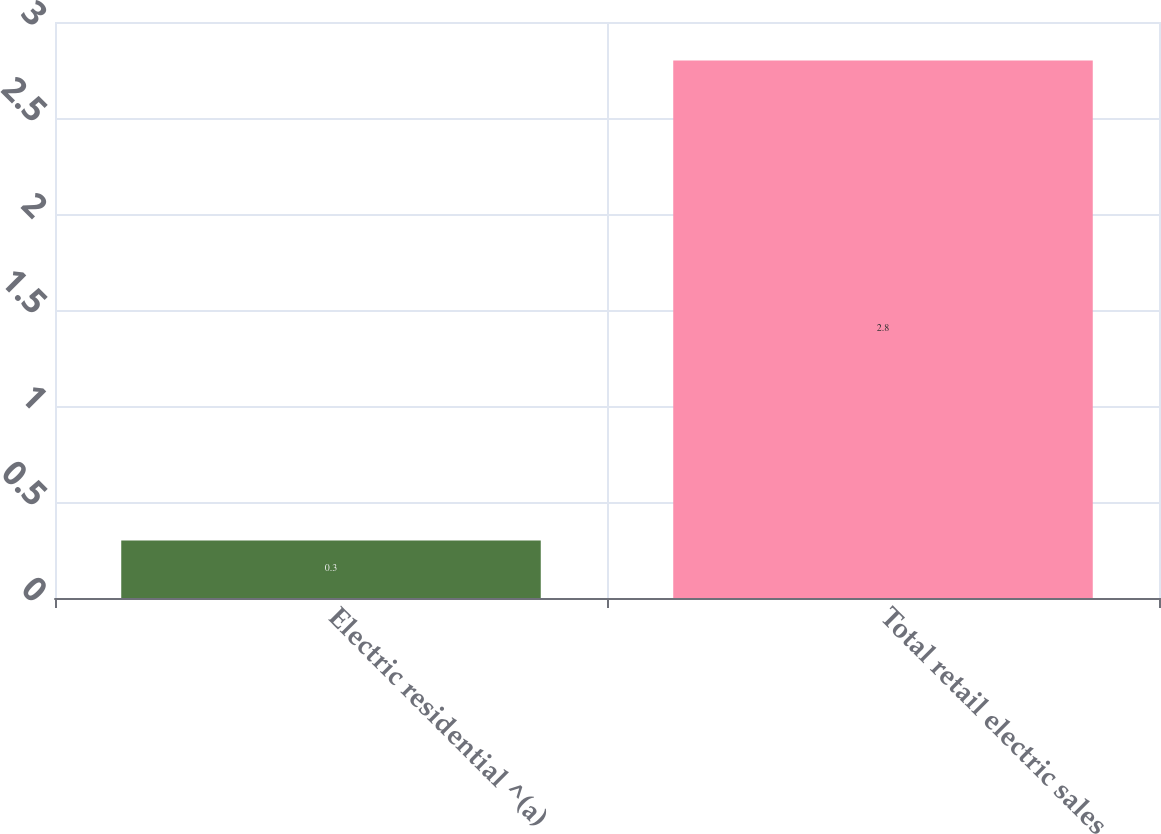Convert chart. <chart><loc_0><loc_0><loc_500><loc_500><bar_chart><fcel>Electric residential ^(a)<fcel>Total retail electric sales<nl><fcel>0.3<fcel>2.8<nl></chart> 